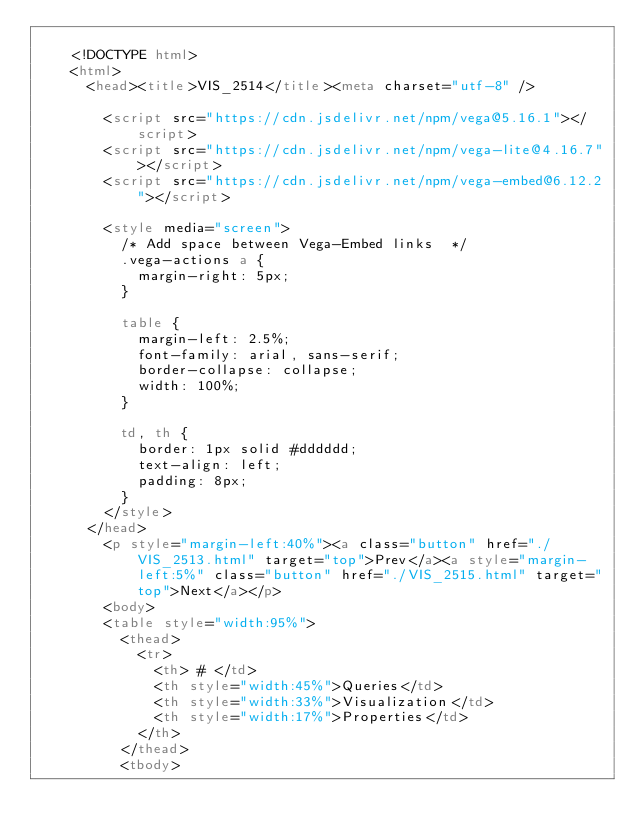Convert code to text. <code><loc_0><loc_0><loc_500><loc_500><_HTML_>
    <!DOCTYPE html>
    <html>
      <head><title>VIS_2514</title><meta charset="utf-8" />

        <script src="https://cdn.jsdelivr.net/npm/vega@5.16.1"></script>
        <script src="https://cdn.jsdelivr.net/npm/vega-lite@4.16.7"></script>
        <script src="https://cdn.jsdelivr.net/npm/vega-embed@6.12.2"></script>

        <style media="screen">
          /* Add space between Vega-Embed links  */
          .vega-actions a {
            margin-right: 5px;
          }

          table {
            margin-left: 2.5%;
            font-family: arial, sans-serif;
            border-collapse: collapse;
            width: 100%;
          }

          td, th {
            border: 1px solid #dddddd;
            text-align: left;
            padding: 8px;
          }
        </style>
      </head>
        <p style="margin-left:40%"><a class="button" href="./VIS_2513.html" target="top">Prev</a><a style="margin-left:5%" class="button" href="./VIS_2515.html" target="top">Next</a></p>
        <body>
        <table style="width:95%">
          <thead>
            <tr>
              <th> # </td>
              <th style="width:45%">Queries</td>
              <th style="width:33%">Visualization</td>
              <th style="width:17%">Properties</td>
            </th>
          </thead>
          <tbody></code> 